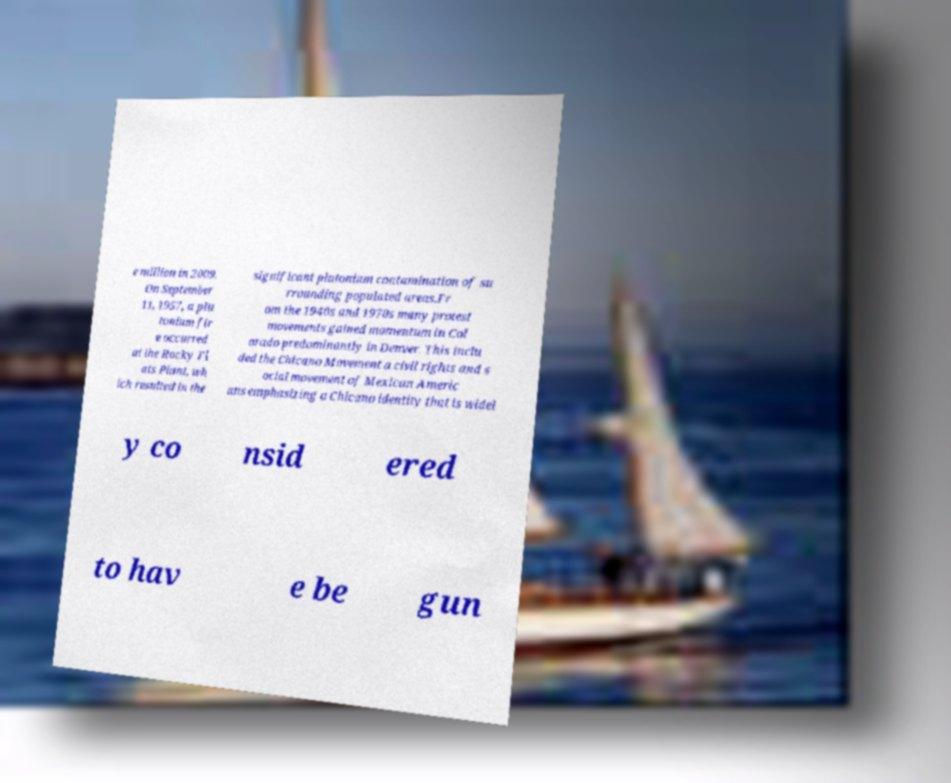For documentation purposes, I need the text within this image transcribed. Could you provide that? e million in 2009. On September 11, 1957, a plu tonium fir e occurred at the Rocky Fl ats Plant, wh ich resulted in the significant plutonium contamination of su rrounding populated areas.Fr om the 1940s and 1970s many protest movements gained momentum in Col orado predominantly in Denver. This inclu ded the Chicano Movement a civil rights and s ocial movement of Mexican Americ ans emphasizing a Chicano identity that is widel y co nsid ered to hav e be gun 